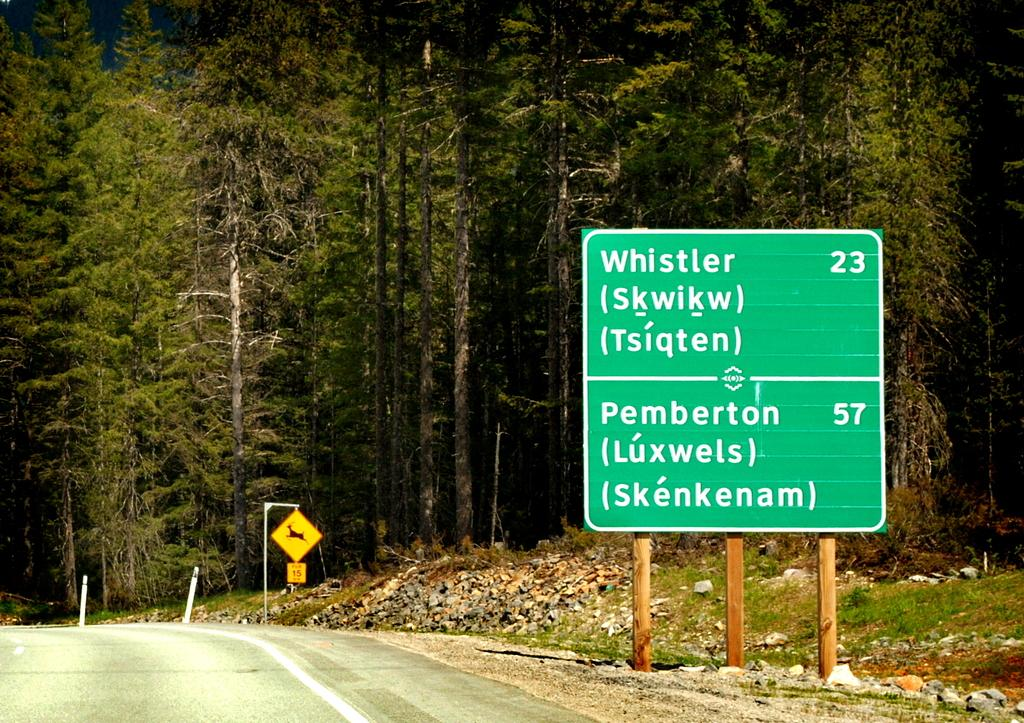What can be seen on the poles in the image? There are poles with directional boards in the image. What information is provided on the poles? There are sign boards on the poles that provide information. What can be seen in the background behind the boards? Trees and stones are visible behind the boards. What is on the left side of the boards? There is a road on the left side of the boards. Can you see a tiger biting an iron rod in the image? No, there is no tiger or iron rod present in the image. 